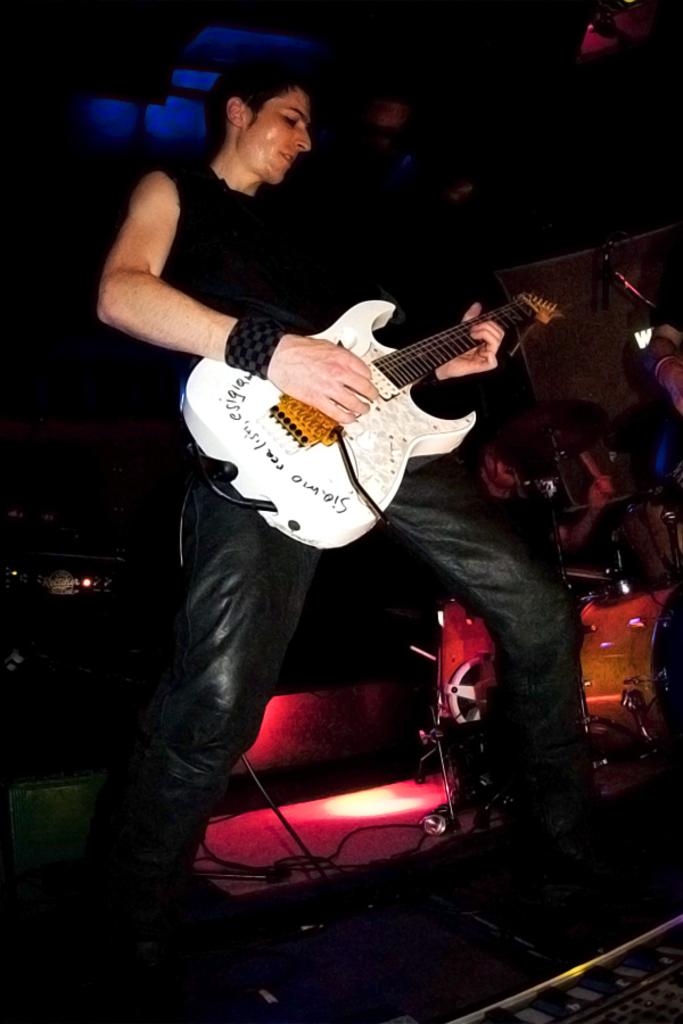What is the main subject of the image? There is a man in the image. What is the man holding in his hand? The man is holding a guitar in his hand. How many legs does the toothpaste have in the image? There is no toothpaste present in the image, so it cannot be determined how many legs it might have. 